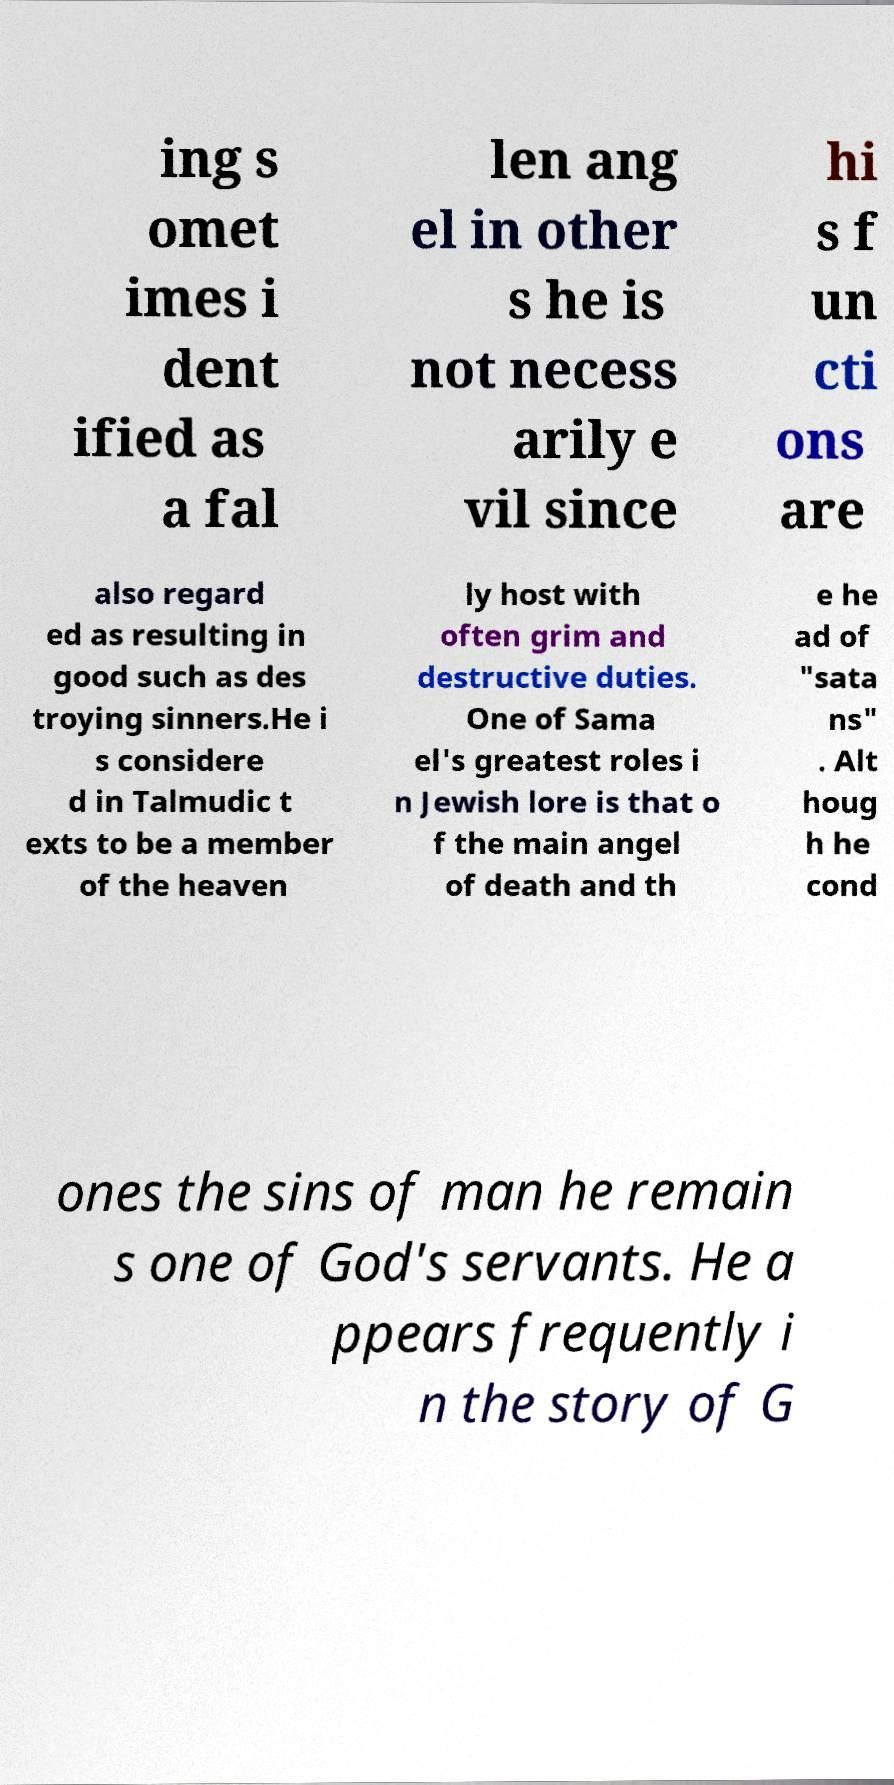For documentation purposes, I need the text within this image transcribed. Could you provide that? ing s omet imes i dent ified as a fal len ang el in other s he is not necess arily e vil since hi s f un cti ons are also regard ed as resulting in good such as des troying sinners.He i s considere d in Talmudic t exts to be a member of the heaven ly host with often grim and destructive duties. One of Sama el's greatest roles i n Jewish lore is that o f the main angel of death and th e he ad of "sata ns" . Alt houg h he cond ones the sins of man he remain s one of God's servants. He a ppears frequently i n the story of G 